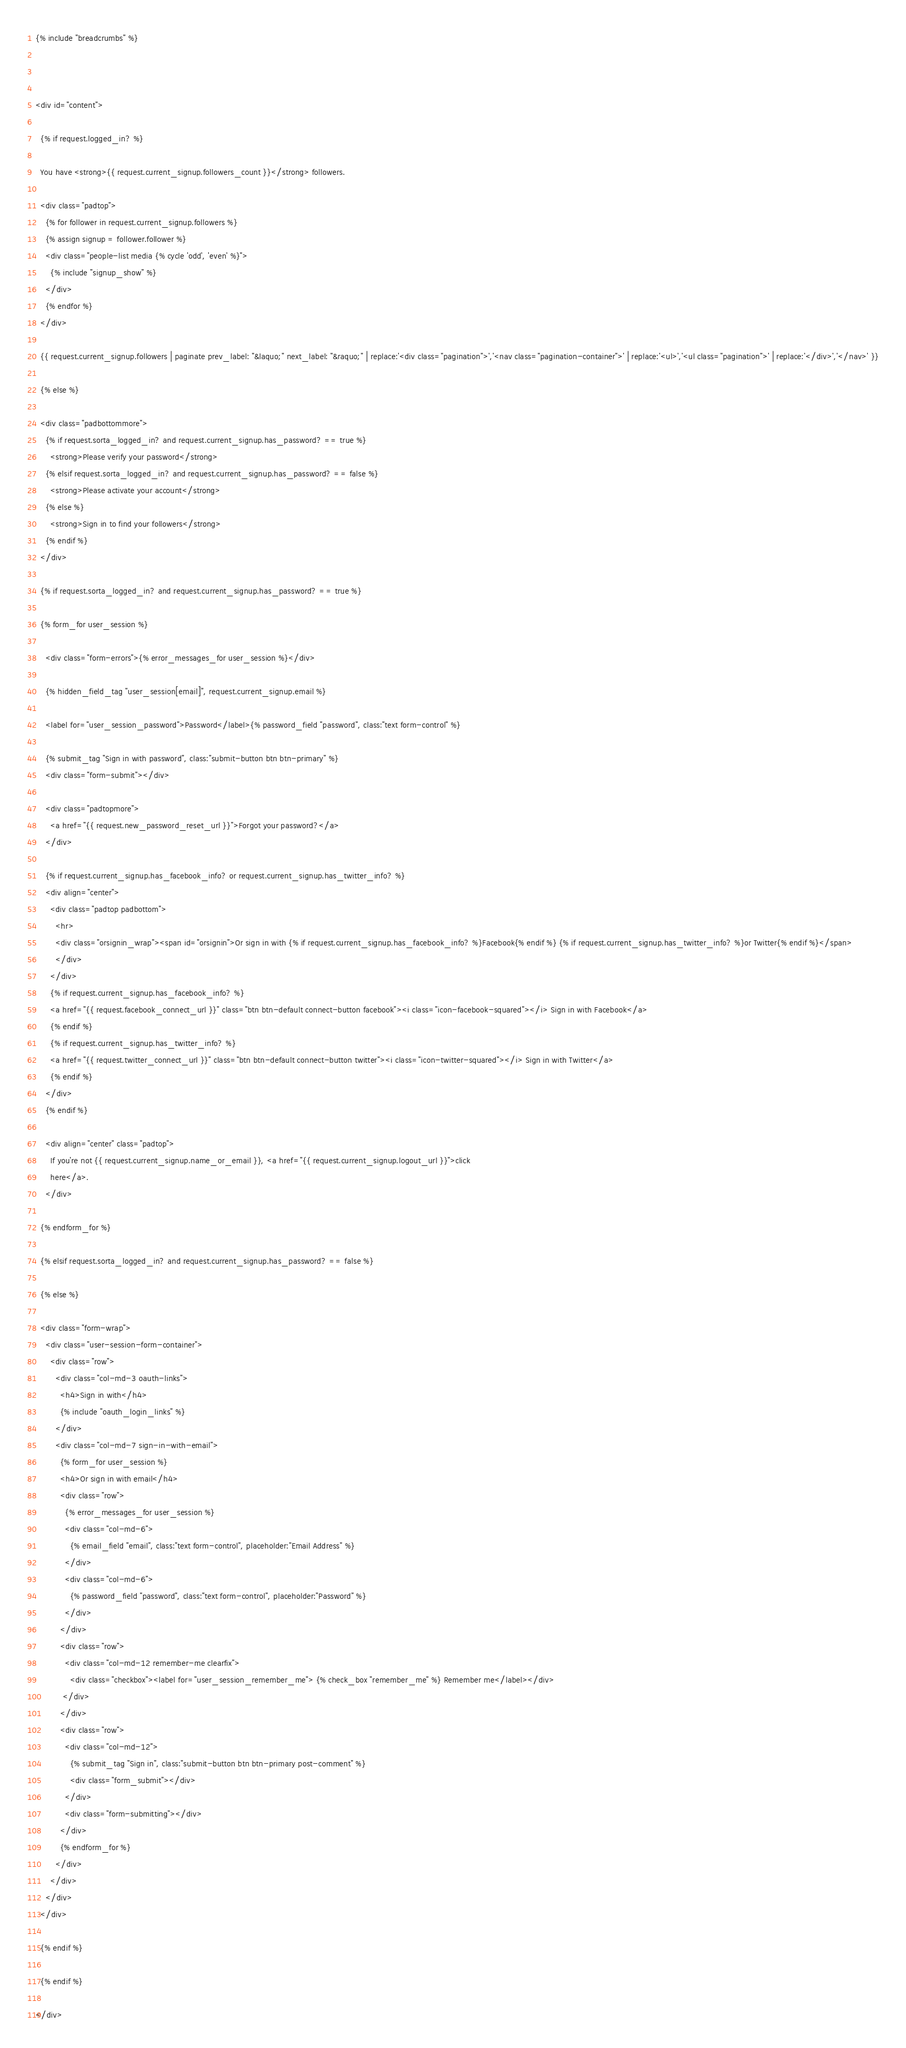Convert code to text. <code><loc_0><loc_0><loc_500><loc_500><_HTML_>{% include "breadcrumbs" %}



<div id="content">

  {% if request.logged_in? %}

  You have <strong>{{ request.current_signup.followers_count }}</strong> followers.

  <div class="padtop">
    {% for follower in request.current_signup.followers %}
    {% assign signup = follower.follower %}
    <div class="people-list media {% cycle 'odd', 'even' %}">
      {% include "signup_show" %}
    </div>
    {% endfor %}
  </div>

  {{ request.current_signup.followers | paginate prev_label: "&laquo;" next_label: "&raquo;" | replace:'<div class="pagination">','<nav class="pagination-container">' | replace:'<ul>','<ul class="pagination">' | replace:'</div>','</nav>' }}

  {% else %}

  <div class="padbottommore">
    {% if request.sorta_logged_in? and request.current_signup.has_password? == true %}
      <strong>Please verify your password</strong>
    {% elsif request.sorta_logged_in? and request.current_signup.has_password? == false %}
      <strong>Please activate your account</strong>
    {% else %}
      <strong>Sign in to find your followers</strong>
    {% endif %}
  </div>

  {% if request.sorta_logged_in? and request.current_signup.has_password? == true %}

  {% form_for user_session %}

    <div class="form-errors">{% error_messages_for user_session %}</div>

    {% hidden_field_tag "user_session[email]", request.current_signup.email %}

    <label for="user_session_password">Password</label>{% password_field "password", class:"text form-control" %}

    {% submit_tag "Sign in with password", class:"submit-button btn btn-primary" %}
    <div class="form-submit"></div>

    <div class="padtopmore">
      <a href="{{ request.new_password_reset_url }}">Forgot your password?</a>
    </div>

    {% if request.current_signup.has_facebook_info? or request.current_signup.has_twitter_info? %}
    <div align="center">
      <div class="padtop padbottom">
        <hr>
        <div class="orsignin_wrap"><span id="orsignin">Or sign in with {% if request.current_signup.has_facebook_info? %}Facebook{% endif %} {% if request.current_signup.has_twitter_info? %}or Twitter{% endif %}</span>
        </div>
      </div>
      {% if request.current_signup.has_facebook_info? %}
      <a href="{{ request.facebook_connect_url }}" class="btn btn-default connect-button facebook"><i class="icon-facebook-squared"></i> Sign in with Facebook</a>
      {% endif %}
      {% if request.current_signup.has_twitter_info? %}
      <a href="{{ request.twitter_connect_url }}" class="btn btn-default connect-button twitter"><i class="icon-twitter-squared"></i> Sign in with Twitter</a>
      {% endif %}
    </div>
    {% endif %}

    <div align="center" class="padtop">
      If you're not {{ request.current_signup.name_or_email }}, <a href="{{ request.current_signup.logout_url }}">click
      here</a>.
    </div>

  {% endform_for %}

  {% elsif request.sorta_logged_in? and request.current_signup.has_password? == false %}

  {% else %}

  <div class="form-wrap">
    <div class="user-session-form-container">
      <div class="row">
        <div class="col-md-3 oauth-links">
          <h4>Sign in with</h4>
          {% include "oauth_login_links" %}
        </div>
        <div class="col-md-7 sign-in-with-email">
          {% form_for user_session %}
          <h4>Or sign in with email</h4>
          <div class="row">
            {% error_messages_for user_session %}
            <div class="col-md-6">
              {% email_field "email", class:"text form-control", placeholder:"Email Address" %}
            </div>
            <div class="col-md-6">
              {% password_field "password", class:"text form-control", placeholder:"Password" %}
            </div>
          </div>
          <div class="row">
            <div class="col-md-12 remember-me clearfix">
              <div class="checkbox"><label for="user_session_remember_me"> {% check_box "remember_me" %} Remember me</label></div>
           </div>
          </div>
          <div class="row">
            <div class="col-md-12">
              {% submit_tag "Sign in", class:"submit-button btn btn-primary post-comment" %}
              <div class="form_submit"></div>
            </div>
            <div class="form-submitting"></div>
          </div>
          {% endform_for %}
        </div>
      </div>
    </div>
  </div>

  {% endif %}

  {% endif %}

</div></code> 